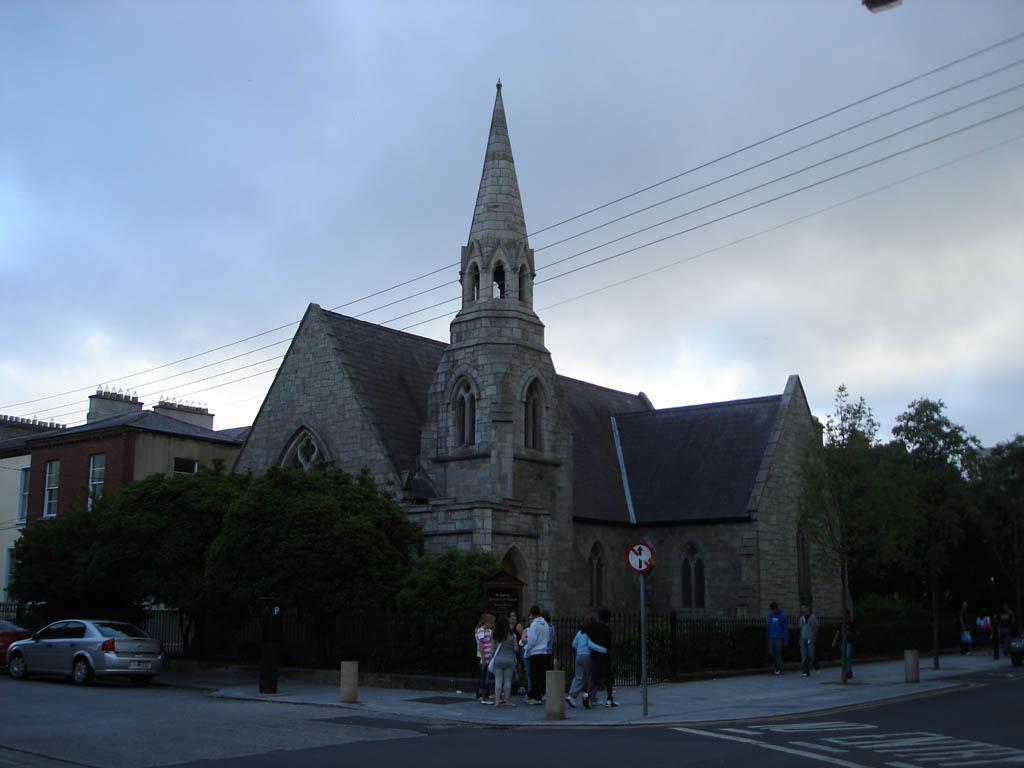How would you summarize this image in a sentence or two? In this image we can see few houses and vehicles. There are few electrical cables in the image. There is a cloudy sky in the image. There are many people in the image. We can see a few people are walking on the footpath. There is a pole and a sign board in the image. There is a road in the image. 